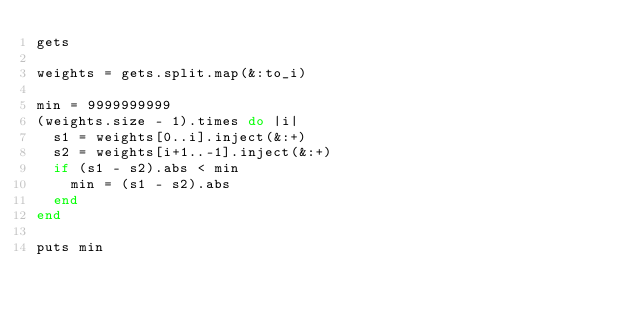<code> <loc_0><loc_0><loc_500><loc_500><_Ruby_>gets

weights = gets.split.map(&:to_i)

min = 9999999999
(weights.size - 1).times do |i|
  s1 = weights[0..i].inject(&:+)
  s2 = weights[i+1..-1].inject(&:+)
  if (s1 - s2).abs < min
    min = (s1 - s2).abs
  end
end

puts min</code> 